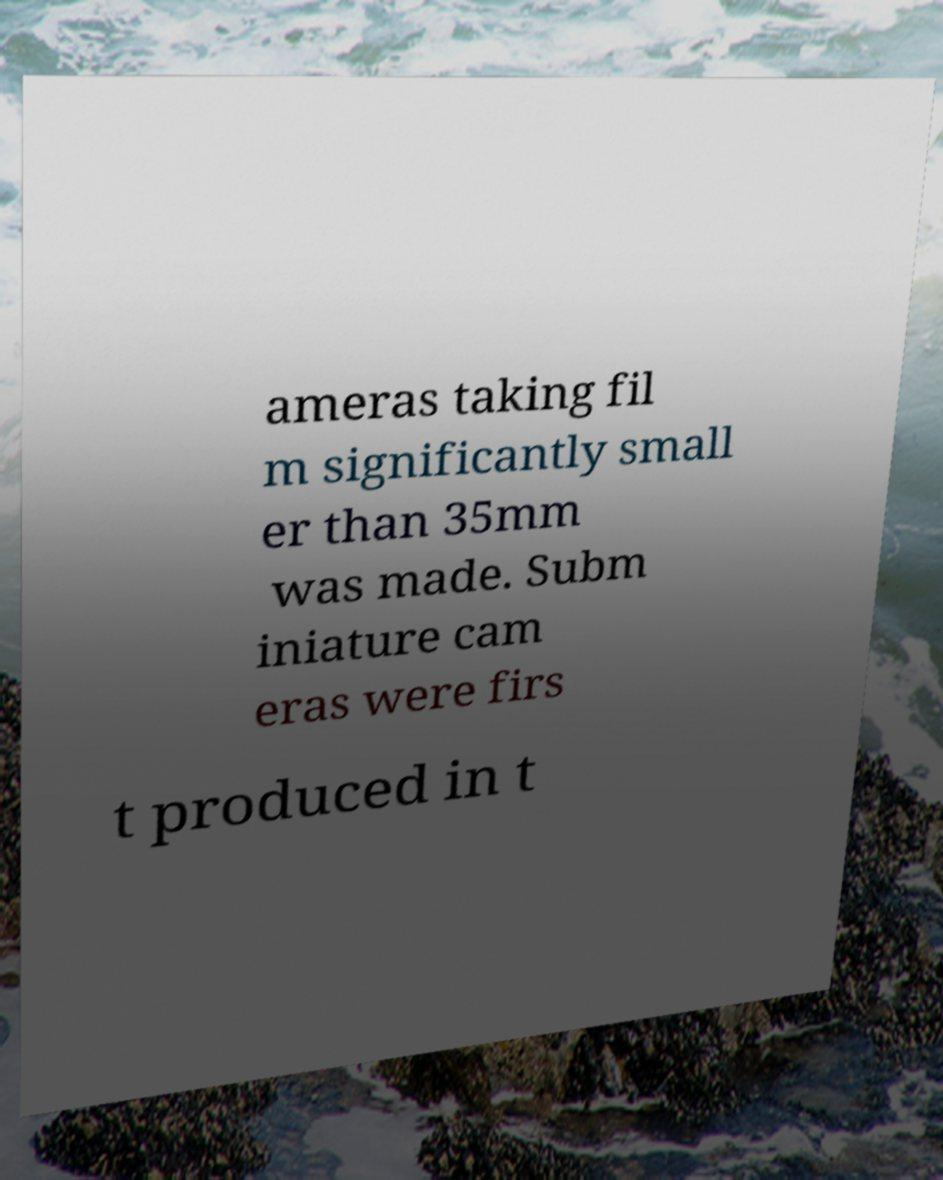Can you read and provide the text displayed in the image?This photo seems to have some interesting text. Can you extract and type it out for me? ameras taking fil m significantly small er than 35mm was made. Subm iniature cam eras were firs t produced in t 